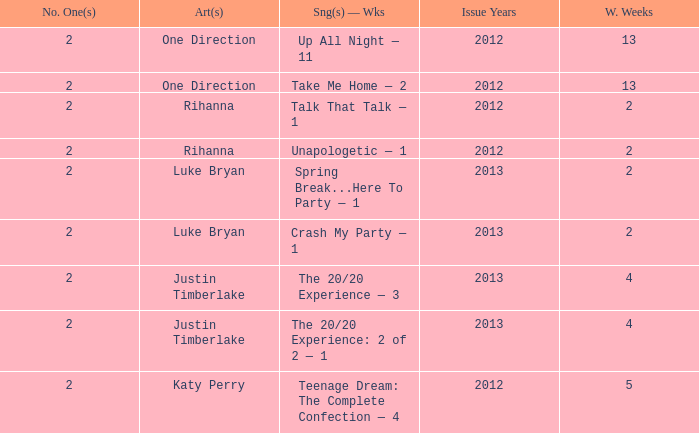What is the longest number of weeks any 1 song was at number #1? 13.0. 